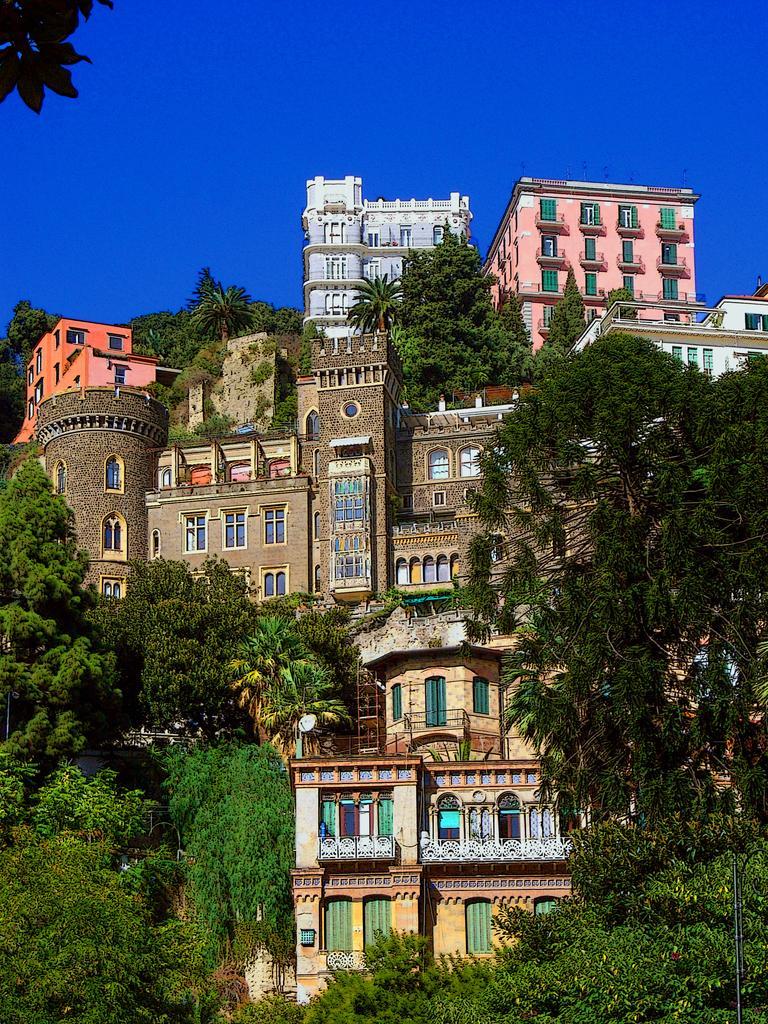Please provide a concise description of this image. There are buildings and trees in the foreground area of the image and the sky in the background. 